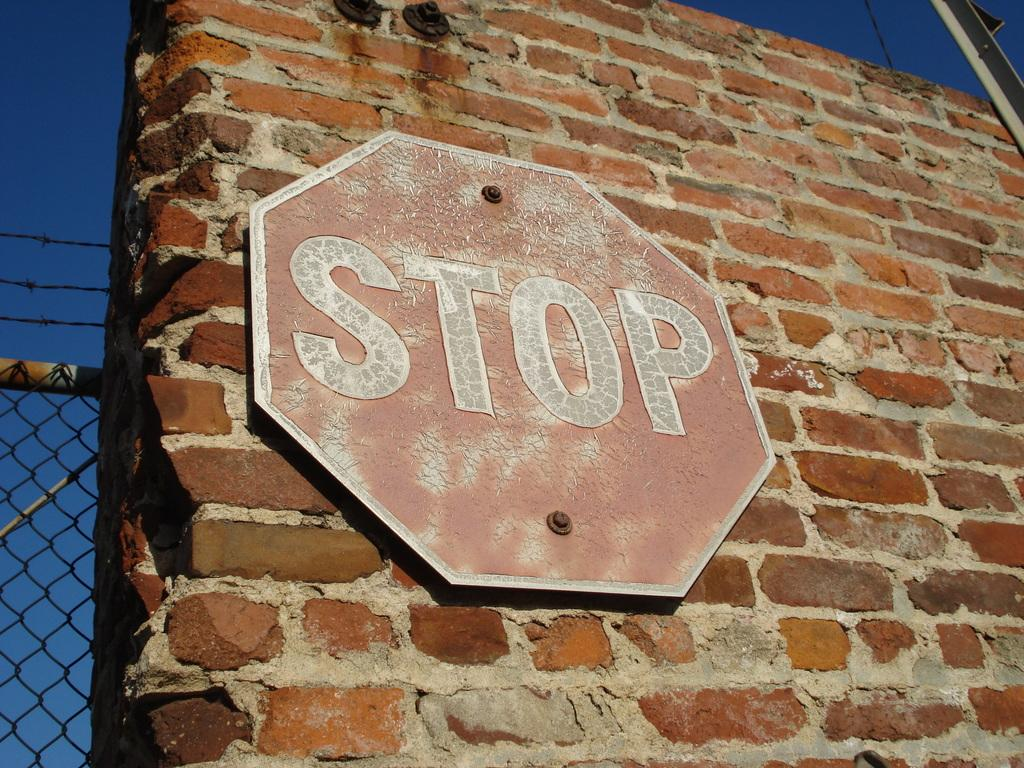<image>
Create a compact narrative representing the image presented. A faded red Stop sign hanging on a brick wall next to a chain link fence. 